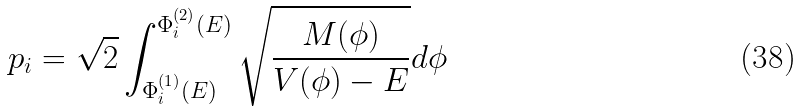<formula> <loc_0><loc_0><loc_500><loc_500>p _ { i } = \sqrt { 2 } \int _ { \Phi _ { i } ^ { ( 1 ) } ( E ) } ^ { \Phi _ { i } ^ { ( 2 ) } ( E ) } \sqrt { \frac { M ( \phi ) } { V ( \phi ) - E } } d \phi</formula> 